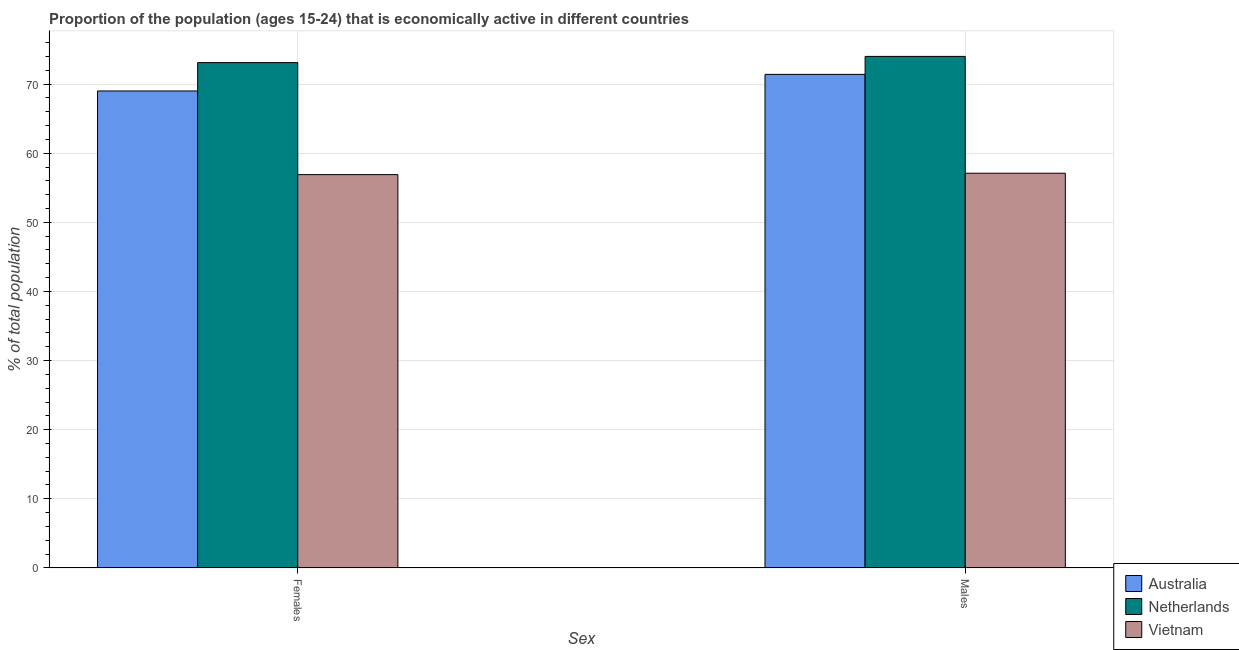How many different coloured bars are there?
Offer a terse response. 3. How many groups of bars are there?
Make the answer very short. 2. How many bars are there on the 1st tick from the left?
Ensure brevity in your answer.  3. What is the label of the 2nd group of bars from the left?
Offer a very short reply. Males. Across all countries, what is the maximum percentage of economically active male population?
Provide a succinct answer. 74. Across all countries, what is the minimum percentage of economically active male population?
Your answer should be very brief. 57.1. In which country was the percentage of economically active male population maximum?
Provide a short and direct response. Netherlands. In which country was the percentage of economically active female population minimum?
Your answer should be compact. Vietnam. What is the total percentage of economically active male population in the graph?
Your answer should be very brief. 202.5. What is the difference between the percentage of economically active male population in Australia and that in Vietnam?
Give a very brief answer. 14.3. What is the difference between the percentage of economically active female population in Vietnam and the percentage of economically active male population in Netherlands?
Provide a short and direct response. -17.1. What is the average percentage of economically active male population per country?
Ensure brevity in your answer.  67.5. What is the difference between the percentage of economically active female population and percentage of economically active male population in Netherlands?
Keep it short and to the point. -0.9. In how many countries, is the percentage of economically active female population greater than 60 %?
Offer a very short reply. 2. What is the ratio of the percentage of economically active male population in Vietnam to that in Australia?
Your answer should be compact. 0.8. What does the 1st bar from the left in Males represents?
Make the answer very short. Australia. What does the 3rd bar from the right in Females represents?
Give a very brief answer. Australia. How many bars are there?
Your response must be concise. 6. What is the difference between two consecutive major ticks on the Y-axis?
Make the answer very short. 10. Are the values on the major ticks of Y-axis written in scientific E-notation?
Provide a succinct answer. No. Where does the legend appear in the graph?
Ensure brevity in your answer.  Bottom right. How many legend labels are there?
Offer a terse response. 3. What is the title of the graph?
Offer a very short reply. Proportion of the population (ages 15-24) that is economically active in different countries. What is the label or title of the X-axis?
Provide a short and direct response. Sex. What is the label or title of the Y-axis?
Provide a short and direct response. % of total population. What is the % of total population in Netherlands in Females?
Your answer should be compact. 73.1. What is the % of total population in Vietnam in Females?
Give a very brief answer. 56.9. What is the % of total population in Australia in Males?
Offer a terse response. 71.4. What is the % of total population in Vietnam in Males?
Your response must be concise. 57.1. Across all Sex, what is the maximum % of total population in Australia?
Your response must be concise. 71.4. Across all Sex, what is the maximum % of total population of Vietnam?
Provide a succinct answer. 57.1. Across all Sex, what is the minimum % of total population in Australia?
Make the answer very short. 69. Across all Sex, what is the minimum % of total population of Netherlands?
Provide a succinct answer. 73.1. Across all Sex, what is the minimum % of total population of Vietnam?
Offer a terse response. 56.9. What is the total % of total population in Australia in the graph?
Offer a terse response. 140.4. What is the total % of total population of Netherlands in the graph?
Ensure brevity in your answer.  147.1. What is the total % of total population in Vietnam in the graph?
Provide a succinct answer. 114. What is the difference between the % of total population in Australia in Females and that in Males?
Provide a succinct answer. -2.4. What is the difference between the % of total population in Vietnam in Females and that in Males?
Offer a very short reply. -0.2. What is the difference between the % of total population in Netherlands in Females and the % of total population in Vietnam in Males?
Your answer should be very brief. 16. What is the average % of total population in Australia per Sex?
Your answer should be very brief. 70.2. What is the average % of total population in Netherlands per Sex?
Provide a succinct answer. 73.55. What is the average % of total population of Vietnam per Sex?
Keep it short and to the point. 57. What is the difference between the % of total population in Australia and % of total population in Netherlands in Males?
Keep it short and to the point. -2.6. What is the difference between the % of total population in Netherlands and % of total population in Vietnam in Males?
Your answer should be very brief. 16.9. What is the ratio of the % of total population of Australia in Females to that in Males?
Keep it short and to the point. 0.97. What is the ratio of the % of total population of Netherlands in Females to that in Males?
Your answer should be compact. 0.99. What is the ratio of the % of total population in Vietnam in Females to that in Males?
Your answer should be very brief. 1. What is the difference between the highest and the second highest % of total population of Vietnam?
Keep it short and to the point. 0.2. What is the difference between the highest and the lowest % of total population of Vietnam?
Your response must be concise. 0.2. 